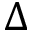<formula> <loc_0><loc_0><loc_500><loc_500>\Delta</formula> 